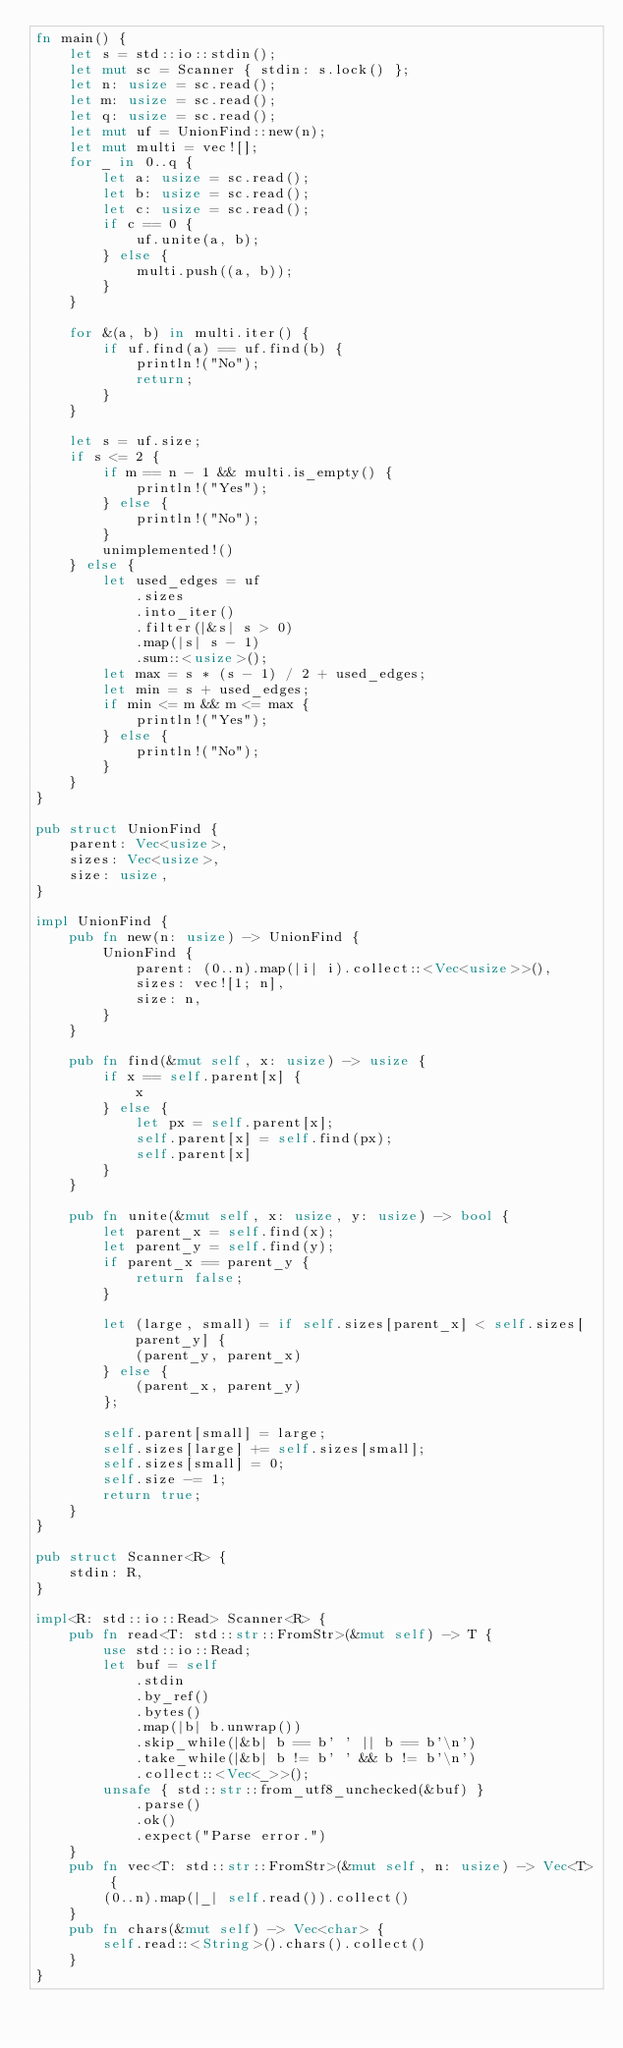<code> <loc_0><loc_0><loc_500><loc_500><_Rust_>fn main() {
    let s = std::io::stdin();
    let mut sc = Scanner { stdin: s.lock() };
    let n: usize = sc.read();
    let m: usize = sc.read();
    let q: usize = sc.read();
    let mut uf = UnionFind::new(n);
    let mut multi = vec![];
    for _ in 0..q {
        let a: usize = sc.read();
        let b: usize = sc.read();
        let c: usize = sc.read();
        if c == 0 {
            uf.unite(a, b);
        } else {
            multi.push((a, b));
        }
    }

    for &(a, b) in multi.iter() {
        if uf.find(a) == uf.find(b) {
            println!("No");
            return;
        }
    }

    let s = uf.size;
    if s <= 2 {
        if m == n - 1 && multi.is_empty() {
            println!("Yes");
        } else {
            println!("No");
        }
        unimplemented!()
    } else {
        let used_edges = uf
            .sizes
            .into_iter()
            .filter(|&s| s > 0)
            .map(|s| s - 1)
            .sum::<usize>();
        let max = s * (s - 1) / 2 + used_edges;
        let min = s + used_edges;
        if min <= m && m <= max {
            println!("Yes");
        } else {
            println!("No");
        }
    }
}

pub struct UnionFind {
    parent: Vec<usize>,
    sizes: Vec<usize>,
    size: usize,
}

impl UnionFind {
    pub fn new(n: usize) -> UnionFind {
        UnionFind {
            parent: (0..n).map(|i| i).collect::<Vec<usize>>(),
            sizes: vec![1; n],
            size: n,
        }
    }

    pub fn find(&mut self, x: usize) -> usize {
        if x == self.parent[x] {
            x
        } else {
            let px = self.parent[x];
            self.parent[x] = self.find(px);
            self.parent[x]
        }
    }

    pub fn unite(&mut self, x: usize, y: usize) -> bool {
        let parent_x = self.find(x);
        let parent_y = self.find(y);
        if parent_x == parent_y {
            return false;
        }

        let (large, small) = if self.sizes[parent_x] < self.sizes[parent_y] {
            (parent_y, parent_x)
        } else {
            (parent_x, parent_y)
        };

        self.parent[small] = large;
        self.sizes[large] += self.sizes[small];
        self.sizes[small] = 0;
        self.size -= 1;
        return true;
    }
}

pub struct Scanner<R> {
    stdin: R,
}

impl<R: std::io::Read> Scanner<R> {
    pub fn read<T: std::str::FromStr>(&mut self) -> T {
        use std::io::Read;
        let buf = self
            .stdin
            .by_ref()
            .bytes()
            .map(|b| b.unwrap())
            .skip_while(|&b| b == b' ' || b == b'\n')
            .take_while(|&b| b != b' ' && b != b'\n')
            .collect::<Vec<_>>();
        unsafe { std::str::from_utf8_unchecked(&buf) }
            .parse()
            .ok()
            .expect("Parse error.")
    }
    pub fn vec<T: std::str::FromStr>(&mut self, n: usize) -> Vec<T> {
        (0..n).map(|_| self.read()).collect()
    }
    pub fn chars(&mut self) -> Vec<char> {
        self.read::<String>().chars().collect()
    }
}
</code> 